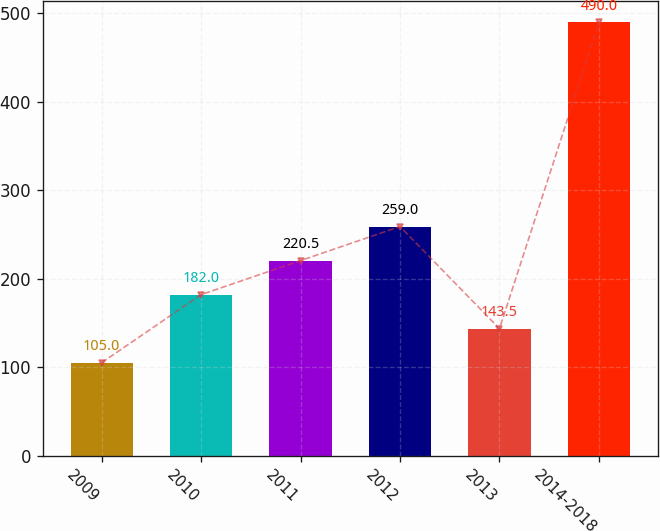<chart> <loc_0><loc_0><loc_500><loc_500><bar_chart><fcel>2009<fcel>2010<fcel>2011<fcel>2012<fcel>2013<fcel>2014-2018<nl><fcel>105<fcel>182<fcel>220.5<fcel>259<fcel>143.5<fcel>490<nl></chart> 